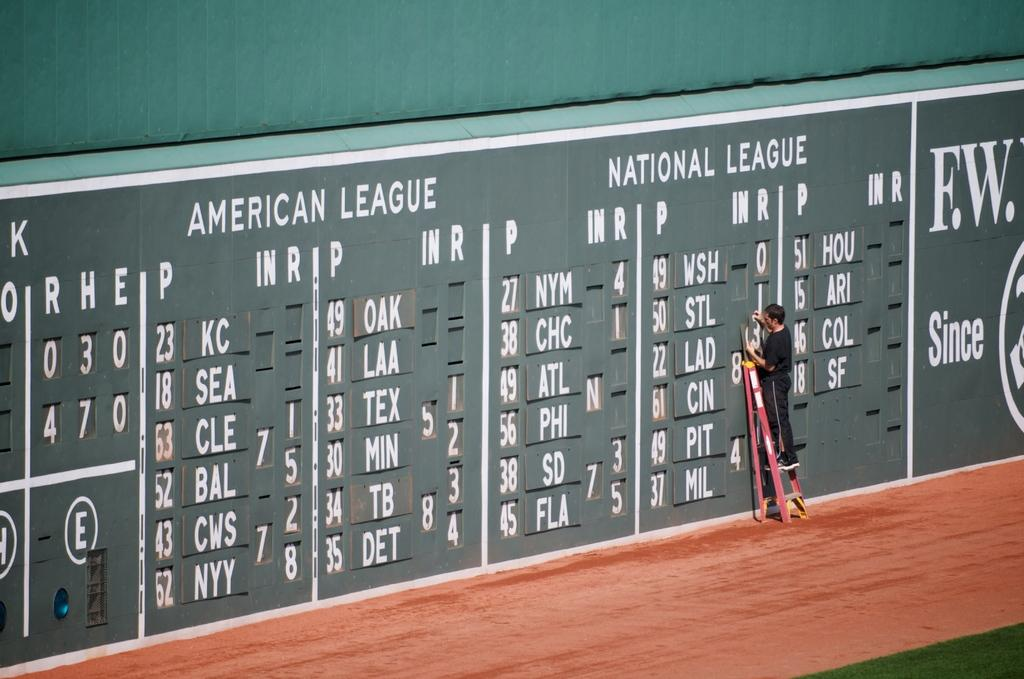<image>
Write a terse but informative summary of the picture. Person updating the scoreboard for the American League and National League. 